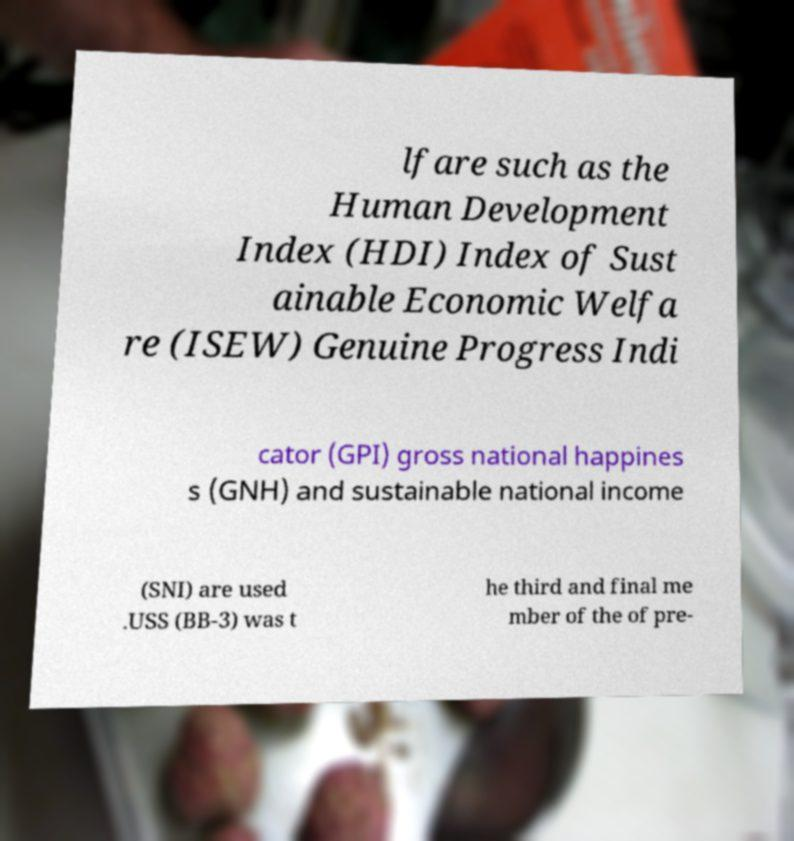There's text embedded in this image that I need extracted. Can you transcribe it verbatim? lfare such as the Human Development Index (HDI) Index of Sust ainable Economic Welfa re (ISEW) Genuine Progress Indi cator (GPI) gross national happines s (GNH) and sustainable national income (SNI) are used .USS (BB-3) was t he third and final me mber of the of pre- 